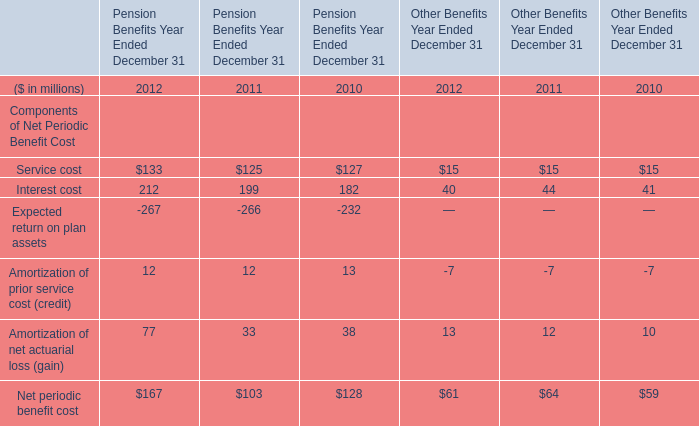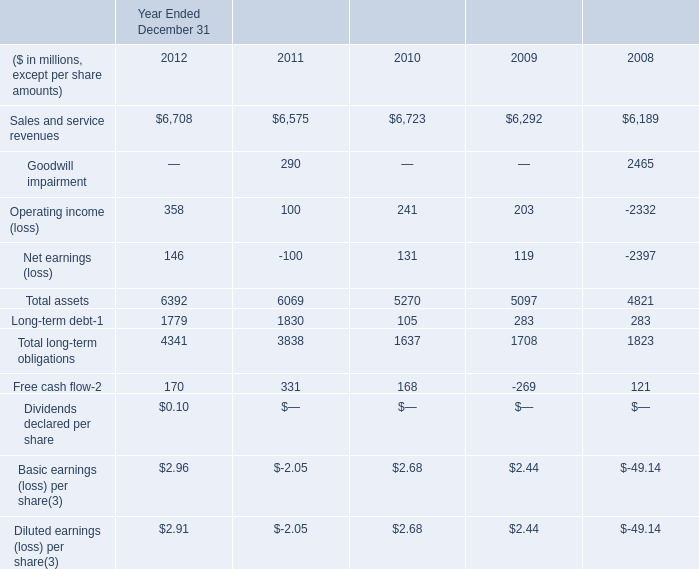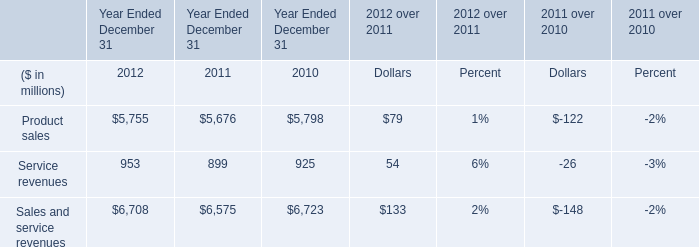What's the average of the Interest cost for Pension Benefits Year Ended December 31 in the years where Product sales for Year Ended December 31 is positive? (in million) 
Computations: (((212 + 199) + 182) / 3)
Answer: 197.66667. 